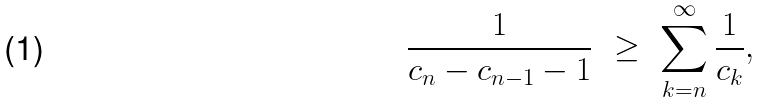<formula> <loc_0><loc_0><loc_500><loc_500>\frac { 1 } { c _ { n } - c _ { n - 1 } - 1 } \ \geq \ \sum _ { k = n } ^ { \infty } \frac { 1 } { c _ { k } } ,</formula> 